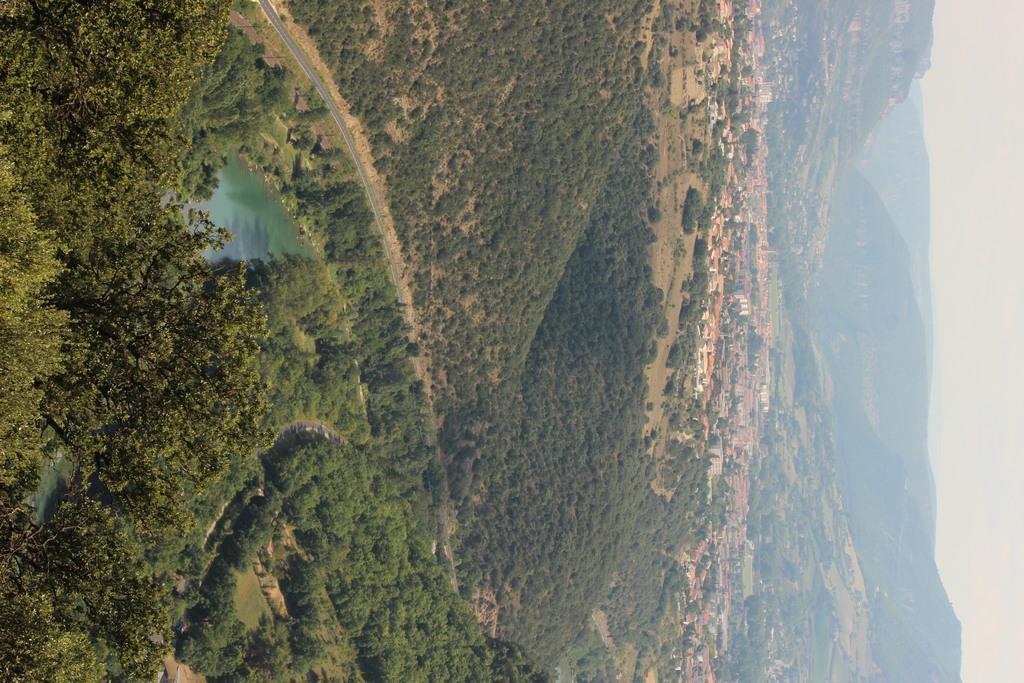Could you give a brief overview of what you see in this image? In this image we can see the trees. And we can see the lake. And we can see the railway track. And we can see the houses. And we can see the towers. And we can see the mountains. And we can see the sky. 